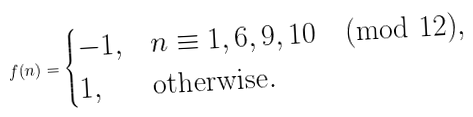Convert formula to latex. <formula><loc_0><loc_0><loc_500><loc_500>f ( n ) = \begin{cases} - 1 , & \text {$n \equiv 1,6,9,10 \pmod{12}$} , \\ 1 , & \text {otherwise} . \end{cases}</formula> 